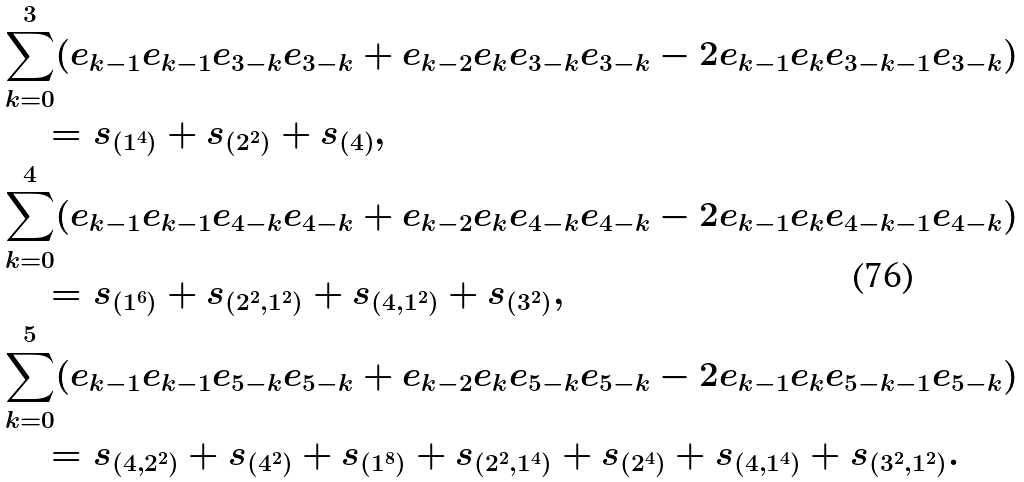Convert formula to latex. <formula><loc_0><loc_0><loc_500><loc_500>& { \sum _ { k = 0 } ^ { 3 } ( e _ { k - 1 } e _ { k - 1 } e _ { 3 - k } e _ { 3 - k } + e _ { k - 2 } e _ { k } e _ { 3 - k } e _ { 3 - k } - 2 e _ { k - 1 } e _ { k } e _ { 3 - k - 1 } e _ { 3 - k } ) } \\ & \quad = s _ { ( 1 ^ { 4 } ) } + s _ { ( 2 ^ { 2 } ) } + s _ { ( 4 ) } , \\ & { \sum _ { k = 0 } ^ { 4 } ( e _ { k - 1 } e _ { k - 1 } e _ { 4 - k } e _ { 4 - k } + e _ { k - 2 } e _ { k } e _ { 4 - k } e _ { 4 - k } - 2 e _ { k - 1 } e _ { k } e _ { 4 - k - 1 } e _ { 4 - k } ) } \\ & \quad = s _ { ( 1 ^ { 6 } ) } + s _ { ( 2 ^ { 2 } , 1 ^ { 2 } ) } + s _ { ( 4 , 1 ^ { 2 } ) } + s _ { ( 3 ^ { 2 } ) } , \\ & { \sum _ { k = 0 } ^ { 5 } ( e _ { k - 1 } e _ { k - 1 } e _ { 5 - k } e _ { 5 - k } + e _ { k - 2 } e _ { k } e _ { 5 - k } e _ { 5 - k } - 2 e _ { k - 1 } e _ { k } e _ { 5 - k - 1 } e _ { 5 - k } ) } \\ & \quad = s _ { ( 4 , 2 ^ { 2 } ) } + s _ { ( 4 ^ { 2 } ) } + s _ { ( 1 ^ { 8 } ) } + s _ { ( 2 ^ { 2 } , 1 ^ { 4 } ) } + s _ { ( 2 ^ { 4 } ) } + s _ { ( 4 , 1 ^ { 4 } ) } + s _ { ( 3 ^ { 2 } , 1 ^ { 2 } ) } .</formula> 